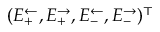Convert formula to latex. <formula><loc_0><loc_0><loc_500><loc_500>( E _ { + } ^ { \leftarrow } , E _ { + } ^ { \rightarrow } , E _ { - } ^ { \leftarrow } , E _ { - } ^ { \rightarrow } ) ^ { \top }</formula> 